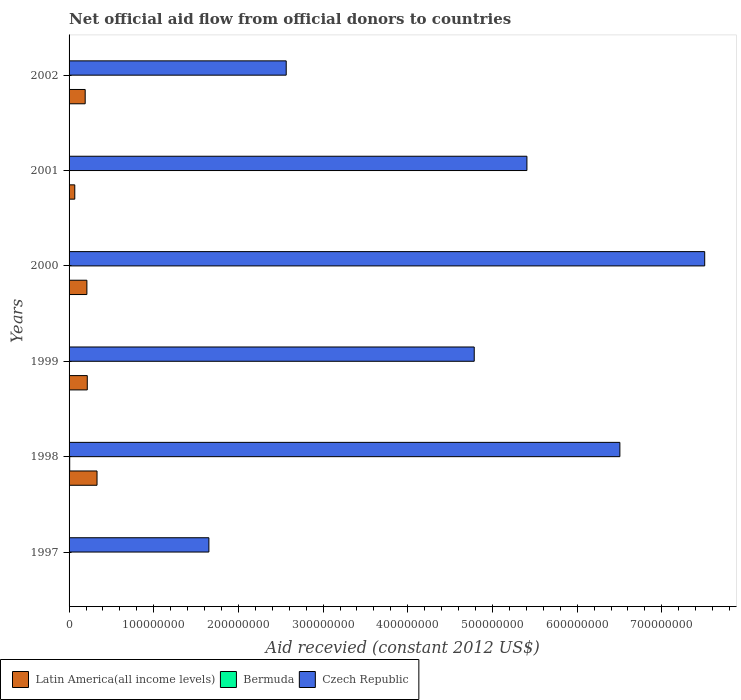What is the label of the 3rd group of bars from the top?
Provide a short and direct response. 2000. What is the total aid received in Bermuda in 1997?
Offer a terse response. 0. Across all years, what is the maximum total aid received in Latin America(all income levels)?
Provide a succinct answer. 3.30e+07. What is the total total aid received in Czech Republic in the graph?
Ensure brevity in your answer.  2.84e+09. What is the difference between the total aid received in Bermuda in 2001 and that in 2002?
Provide a succinct answer. 10000. What is the difference between the total aid received in Czech Republic in 1997 and the total aid received in Latin America(all income levels) in 2002?
Offer a terse response. 1.46e+08. What is the average total aid received in Czech Republic per year?
Offer a terse response. 4.74e+08. In the year 2001, what is the difference between the total aid received in Czech Republic and total aid received in Latin America(all income levels)?
Offer a terse response. 5.34e+08. What is the ratio of the total aid received in Czech Republic in 1997 to that in 1999?
Offer a terse response. 0.35. Is the difference between the total aid received in Czech Republic in 1998 and 2001 greater than the difference between the total aid received in Latin America(all income levels) in 1998 and 2001?
Your answer should be very brief. Yes. What is the difference between the highest and the second highest total aid received in Czech Republic?
Offer a terse response. 1.00e+08. What is the difference between the highest and the lowest total aid received in Bermuda?
Your response must be concise. 7.40e+05. Is it the case that in every year, the sum of the total aid received in Bermuda and total aid received in Czech Republic is greater than the total aid received in Latin America(all income levels)?
Ensure brevity in your answer.  Yes. How many bars are there?
Your answer should be compact. 16. Are all the bars in the graph horizontal?
Make the answer very short. Yes. How many years are there in the graph?
Provide a short and direct response. 6. Are the values on the major ticks of X-axis written in scientific E-notation?
Offer a terse response. No. Does the graph contain any zero values?
Ensure brevity in your answer.  Yes. Where does the legend appear in the graph?
Provide a short and direct response. Bottom left. What is the title of the graph?
Offer a terse response. Net official aid flow from official donors to countries. Does "Namibia" appear as one of the legend labels in the graph?
Provide a short and direct response. No. What is the label or title of the X-axis?
Provide a succinct answer. Aid recevied (constant 2012 US$). What is the Aid recevied (constant 2012 US$) of Czech Republic in 1997?
Give a very brief answer. 1.65e+08. What is the Aid recevied (constant 2012 US$) of Latin America(all income levels) in 1998?
Give a very brief answer. 3.30e+07. What is the Aid recevied (constant 2012 US$) in Bermuda in 1998?
Ensure brevity in your answer.  7.40e+05. What is the Aid recevied (constant 2012 US$) in Czech Republic in 1998?
Provide a short and direct response. 6.50e+08. What is the Aid recevied (constant 2012 US$) in Latin America(all income levels) in 1999?
Ensure brevity in your answer.  2.15e+07. What is the Aid recevied (constant 2012 US$) of Czech Republic in 1999?
Your response must be concise. 4.78e+08. What is the Aid recevied (constant 2012 US$) of Latin America(all income levels) in 2000?
Your response must be concise. 2.10e+07. What is the Aid recevied (constant 2012 US$) in Bermuda in 2000?
Provide a succinct answer. 1.10e+05. What is the Aid recevied (constant 2012 US$) of Czech Republic in 2000?
Offer a very short reply. 7.51e+08. What is the Aid recevied (constant 2012 US$) of Latin America(all income levels) in 2001?
Keep it short and to the point. 6.75e+06. What is the Aid recevied (constant 2012 US$) of Bermuda in 2001?
Your response must be concise. 4.00e+04. What is the Aid recevied (constant 2012 US$) in Czech Republic in 2001?
Provide a short and direct response. 5.41e+08. What is the Aid recevied (constant 2012 US$) of Latin America(all income levels) in 2002?
Your answer should be very brief. 1.90e+07. What is the Aid recevied (constant 2012 US$) in Bermuda in 2002?
Offer a very short reply. 3.00e+04. What is the Aid recevied (constant 2012 US$) of Czech Republic in 2002?
Keep it short and to the point. 2.56e+08. Across all years, what is the maximum Aid recevied (constant 2012 US$) of Latin America(all income levels)?
Offer a very short reply. 3.30e+07. Across all years, what is the maximum Aid recevied (constant 2012 US$) in Bermuda?
Your answer should be very brief. 7.40e+05. Across all years, what is the maximum Aid recevied (constant 2012 US$) in Czech Republic?
Your response must be concise. 7.51e+08. Across all years, what is the minimum Aid recevied (constant 2012 US$) in Latin America(all income levels)?
Offer a very short reply. 0. Across all years, what is the minimum Aid recevied (constant 2012 US$) in Bermuda?
Ensure brevity in your answer.  0. Across all years, what is the minimum Aid recevied (constant 2012 US$) of Czech Republic?
Give a very brief answer. 1.65e+08. What is the total Aid recevied (constant 2012 US$) of Latin America(all income levels) in the graph?
Your answer should be very brief. 1.01e+08. What is the total Aid recevied (constant 2012 US$) of Bermuda in the graph?
Make the answer very short. 1.05e+06. What is the total Aid recevied (constant 2012 US$) of Czech Republic in the graph?
Your answer should be compact. 2.84e+09. What is the difference between the Aid recevied (constant 2012 US$) of Czech Republic in 1997 and that in 1998?
Offer a very short reply. -4.85e+08. What is the difference between the Aid recevied (constant 2012 US$) of Czech Republic in 1997 and that in 1999?
Provide a short and direct response. -3.13e+08. What is the difference between the Aid recevied (constant 2012 US$) of Czech Republic in 1997 and that in 2000?
Offer a very short reply. -5.86e+08. What is the difference between the Aid recevied (constant 2012 US$) in Czech Republic in 1997 and that in 2001?
Your answer should be very brief. -3.76e+08. What is the difference between the Aid recevied (constant 2012 US$) in Czech Republic in 1997 and that in 2002?
Your response must be concise. -9.13e+07. What is the difference between the Aid recevied (constant 2012 US$) of Latin America(all income levels) in 1998 and that in 1999?
Offer a very short reply. 1.15e+07. What is the difference between the Aid recevied (constant 2012 US$) of Bermuda in 1998 and that in 1999?
Provide a succinct answer. 6.10e+05. What is the difference between the Aid recevied (constant 2012 US$) in Czech Republic in 1998 and that in 1999?
Offer a terse response. 1.72e+08. What is the difference between the Aid recevied (constant 2012 US$) of Latin America(all income levels) in 1998 and that in 2000?
Keep it short and to the point. 1.20e+07. What is the difference between the Aid recevied (constant 2012 US$) in Bermuda in 1998 and that in 2000?
Ensure brevity in your answer.  6.30e+05. What is the difference between the Aid recevied (constant 2012 US$) of Czech Republic in 1998 and that in 2000?
Ensure brevity in your answer.  -1.00e+08. What is the difference between the Aid recevied (constant 2012 US$) of Latin America(all income levels) in 1998 and that in 2001?
Offer a terse response. 2.63e+07. What is the difference between the Aid recevied (constant 2012 US$) in Czech Republic in 1998 and that in 2001?
Provide a succinct answer. 1.10e+08. What is the difference between the Aid recevied (constant 2012 US$) in Latin America(all income levels) in 1998 and that in 2002?
Offer a terse response. 1.40e+07. What is the difference between the Aid recevied (constant 2012 US$) in Bermuda in 1998 and that in 2002?
Offer a very short reply. 7.10e+05. What is the difference between the Aid recevied (constant 2012 US$) of Czech Republic in 1998 and that in 2002?
Ensure brevity in your answer.  3.94e+08. What is the difference between the Aid recevied (constant 2012 US$) of Latin America(all income levels) in 1999 and that in 2000?
Ensure brevity in your answer.  4.50e+05. What is the difference between the Aid recevied (constant 2012 US$) of Czech Republic in 1999 and that in 2000?
Offer a terse response. -2.72e+08. What is the difference between the Aid recevied (constant 2012 US$) in Latin America(all income levels) in 1999 and that in 2001?
Your answer should be compact. 1.48e+07. What is the difference between the Aid recevied (constant 2012 US$) in Czech Republic in 1999 and that in 2001?
Make the answer very short. -6.22e+07. What is the difference between the Aid recevied (constant 2012 US$) of Latin America(all income levels) in 1999 and that in 2002?
Your answer should be compact. 2.47e+06. What is the difference between the Aid recevied (constant 2012 US$) of Bermuda in 1999 and that in 2002?
Your response must be concise. 1.00e+05. What is the difference between the Aid recevied (constant 2012 US$) of Czech Republic in 1999 and that in 2002?
Make the answer very short. 2.22e+08. What is the difference between the Aid recevied (constant 2012 US$) in Latin America(all income levels) in 2000 and that in 2001?
Ensure brevity in your answer.  1.43e+07. What is the difference between the Aid recevied (constant 2012 US$) of Bermuda in 2000 and that in 2001?
Your answer should be very brief. 7.00e+04. What is the difference between the Aid recevied (constant 2012 US$) of Czech Republic in 2000 and that in 2001?
Give a very brief answer. 2.10e+08. What is the difference between the Aid recevied (constant 2012 US$) in Latin America(all income levels) in 2000 and that in 2002?
Your answer should be very brief. 2.02e+06. What is the difference between the Aid recevied (constant 2012 US$) of Czech Republic in 2000 and that in 2002?
Offer a very short reply. 4.94e+08. What is the difference between the Aid recevied (constant 2012 US$) in Latin America(all income levels) in 2001 and that in 2002?
Your answer should be compact. -1.23e+07. What is the difference between the Aid recevied (constant 2012 US$) in Bermuda in 2001 and that in 2002?
Provide a succinct answer. 10000. What is the difference between the Aid recevied (constant 2012 US$) of Czech Republic in 2001 and that in 2002?
Give a very brief answer. 2.84e+08. What is the difference between the Aid recevied (constant 2012 US$) in Latin America(all income levels) in 1998 and the Aid recevied (constant 2012 US$) in Bermuda in 1999?
Make the answer very short. 3.29e+07. What is the difference between the Aid recevied (constant 2012 US$) in Latin America(all income levels) in 1998 and the Aid recevied (constant 2012 US$) in Czech Republic in 1999?
Offer a terse response. -4.45e+08. What is the difference between the Aid recevied (constant 2012 US$) in Bermuda in 1998 and the Aid recevied (constant 2012 US$) in Czech Republic in 1999?
Give a very brief answer. -4.78e+08. What is the difference between the Aid recevied (constant 2012 US$) in Latin America(all income levels) in 1998 and the Aid recevied (constant 2012 US$) in Bermuda in 2000?
Offer a very short reply. 3.29e+07. What is the difference between the Aid recevied (constant 2012 US$) of Latin America(all income levels) in 1998 and the Aid recevied (constant 2012 US$) of Czech Republic in 2000?
Your response must be concise. -7.18e+08. What is the difference between the Aid recevied (constant 2012 US$) in Bermuda in 1998 and the Aid recevied (constant 2012 US$) in Czech Republic in 2000?
Ensure brevity in your answer.  -7.50e+08. What is the difference between the Aid recevied (constant 2012 US$) of Latin America(all income levels) in 1998 and the Aid recevied (constant 2012 US$) of Bermuda in 2001?
Keep it short and to the point. 3.30e+07. What is the difference between the Aid recevied (constant 2012 US$) of Latin America(all income levels) in 1998 and the Aid recevied (constant 2012 US$) of Czech Republic in 2001?
Make the answer very short. -5.08e+08. What is the difference between the Aid recevied (constant 2012 US$) of Bermuda in 1998 and the Aid recevied (constant 2012 US$) of Czech Republic in 2001?
Provide a succinct answer. -5.40e+08. What is the difference between the Aid recevied (constant 2012 US$) in Latin America(all income levels) in 1998 and the Aid recevied (constant 2012 US$) in Bermuda in 2002?
Offer a terse response. 3.30e+07. What is the difference between the Aid recevied (constant 2012 US$) in Latin America(all income levels) in 1998 and the Aid recevied (constant 2012 US$) in Czech Republic in 2002?
Your response must be concise. -2.23e+08. What is the difference between the Aid recevied (constant 2012 US$) of Bermuda in 1998 and the Aid recevied (constant 2012 US$) of Czech Republic in 2002?
Your answer should be very brief. -2.56e+08. What is the difference between the Aid recevied (constant 2012 US$) of Latin America(all income levels) in 1999 and the Aid recevied (constant 2012 US$) of Bermuda in 2000?
Make the answer very short. 2.14e+07. What is the difference between the Aid recevied (constant 2012 US$) of Latin America(all income levels) in 1999 and the Aid recevied (constant 2012 US$) of Czech Republic in 2000?
Provide a succinct answer. -7.29e+08. What is the difference between the Aid recevied (constant 2012 US$) of Bermuda in 1999 and the Aid recevied (constant 2012 US$) of Czech Republic in 2000?
Keep it short and to the point. -7.50e+08. What is the difference between the Aid recevied (constant 2012 US$) of Latin America(all income levels) in 1999 and the Aid recevied (constant 2012 US$) of Bermuda in 2001?
Ensure brevity in your answer.  2.15e+07. What is the difference between the Aid recevied (constant 2012 US$) of Latin America(all income levels) in 1999 and the Aid recevied (constant 2012 US$) of Czech Republic in 2001?
Make the answer very short. -5.19e+08. What is the difference between the Aid recevied (constant 2012 US$) of Bermuda in 1999 and the Aid recevied (constant 2012 US$) of Czech Republic in 2001?
Your answer should be very brief. -5.41e+08. What is the difference between the Aid recevied (constant 2012 US$) of Latin America(all income levels) in 1999 and the Aid recevied (constant 2012 US$) of Bermuda in 2002?
Offer a terse response. 2.15e+07. What is the difference between the Aid recevied (constant 2012 US$) in Latin America(all income levels) in 1999 and the Aid recevied (constant 2012 US$) in Czech Republic in 2002?
Give a very brief answer. -2.35e+08. What is the difference between the Aid recevied (constant 2012 US$) of Bermuda in 1999 and the Aid recevied (constant 2012 US$) of Czech Republic in 2002?
Provide a short and direct response. -2.56e+08. What is the difference between the Aid recevied (constant 2012 US$) in Latin America(all income levels) in 2000 and the Aid recevied (constant 2012 US$) in Bermuda in 2001?
Your answer should be very brief. 2.10e+07. What is the difference between the Aid recevied (constant 2012 US$) in Latin America(all income levels) in 2000 and the Aid recevied (constant 2012 US$) in Czech Republic in 2001?
Keep it short and to the point. -5.20e+08. What is the difference between the Aid recevied (constant 2012 US$) in Bermuda in 2000 and the Aid recevied (constant 2012 US$) in Czech Republic in 2001?
Offer a very short reply. -5.41e+08. What is the difference between the Aid recevied (constant 2012 US$) in Latin America(all income levels) in 2000 and the Aid recevied (constant 2012 US$) in Bermuda in 2002?
Your answer should be compact. 2.10e+07. What is the difference between the Aid recevied (constant 2012 US$) in Latin America(all income levels) in 2000 and the Aid recevied (constant 2012 US$) in Czech Republic in 2002?
Your answer should be very brief. -2.35e+08. What is the difference between the Aid recevied (constant 2012 US$) of Bermuda in 2000 and the Aid recevied (constant 2012 US$) of Czech Republic in 2002?
Your answer should be compact. -2.56e+08. What is the difference between the Aid recevied (constant 2012 US$) in Latin America(all income levels) in 2001 and the Aid recevied (constant 2012 US$) in Bermuda in 2002?
Offer a very short reply. 6.72e+06. What is the difference between the Aid recevied (constant 2012 US$) in Latin America(all income levels) in 2001 and the Aid recevied (constant 2012 US$) in Czech Republic in 2002?
Offer a terse response. -2.50e+08. What is the difference between the Aid recevied (constant 2012 US$) of Bermuda in 2001 and the Aid recevied (constant 2012 US$) of Czech Republic in 2002?
Offer a very short reply. -2.56e+08. What is the average Aid recevied (constant 2012 US$) of Latin America(all income levels) per year?
Provide a succinct answer. 1.69e+07. What is the average Aid recevied (constant 2012 US$) in Bermuda per year?
Keep it short and to the point. 1.75e+05. What is the average Aid recevied (constant 2012 US$) in Czech Republic per year?
Ensure brevity in your answer.  4.74e+08. In the year 1998, what is the difference between the Aid recevied (constant 2012 US$) in Latin America(all income levels) and Aid recevied (constant 2012 US$) in Bermuda?
Give a very brief answer. 3.23e+07. In the year 1998, what is the difference between the Aid recevied (constant 2012 US$) of Latin America(all income levels) and Aid recevied (constant 2012 US$) of Czech Republic?
Make the answer very short. -6.17e+08. In the year 1998, what is the difference between the Aid recevied (constant 2012 US$) of Bermuda and Aid recevied (constant 2012 US$) of Czech Republic?
Your response must be concise. -6.50e+08. In the year 1999, what is the difference between the Aid recevied (constant 2012 US$) in Latin America(all income levels) and Aid recevied (constant 2012 US$) in Bermuda?
Offer a terse response. 2.14e+07. In the year 1999, what is the difference between the Aid recevied (constant 2012 US$) of Latin America(all income levels) and Aid recevied (constant 2012 US$) of Czech Republic?
Offer a very short reply. -4.57e+08. In the year 1999, what is the difference between the Aid recevied (constant 2012 US$) of Bermuda and Aid recevied (constant 2012 US$) of Czech Republic?
Offer a terse response. -4.78e+08. In the year 2000, what is the difference between the Aid recevied (constant 2012 US$) in Latin America(all income levels) and Aid recevied (constant 2012 US$) in Bermuda?
Ensure brevity in your answer.  2.09e+07. In the year 2000, what is the difference between the Aid recevied (constant 2012 US$) in Latin America(all income levels) and Aid recevied (constant 2012 US$) in Czech Republic?
Provide a succinct answer. -7.30e+08. In the year 2000, what is the difference between the Aid recevied (constant 2012 US$) of Bermuda and Aid recevied (constant 2012 US$) of Czech Republic?
Ensure brevity in your answer.  -7.51e+08. In the year 2001, what is the difference between the Aid recevied (constant 2012 US$) of Latin America(all income levels) and Aid recevied (constant 2012 US$) of Bermuda?
Your answer should be compact. 6.71e+06. In the year 2001, what is the difference between the Aid recevied (constant 2012 US$) in Latin America(all income levels) and Aid recevied (constant 2012 US$) in Czech Republic?
Your response must be concise. -5.34e+08. In the year 2001, what is the difference between the Aid recevied (constant 2012 US$) of Bermuda and Aid recevied (constant 2012 US$) of Czech Republic?
Make the answer very short. -5.41e+08. In the year 2002, what is the difference between the Aid recevied (constant 2012 US$) of Latin America(all income levels) and Aid recevied (constant 2012 US$) of Bermuda?
Your answer should be compact. 1.90e+07. In the year 2002, what is the difference between the Aid recevied (constant 2012 US$) in Latin America(all income levels) and Aid recevied (constant 2012 US$) in Czech Republic?
Offer a terse response. -2.37e+08. In the year 2002, what is the difference between the Aid recevied (constant 2012 US$) in Bermuda and Aid recevied (constant 2012 US$) in Czech Republic?
Provide a succinct answer. -2.56e+08. What is the ratio of the Aid recevied (constant 2012 US$) of Czech Republic in 1997 to that in 1998?
Give a very brief answer. 0.25. What is the ratio of the Aid recevied (constant 2012 US$) in Czech Republic in 1997 to that in 1999?
Provide a short and direct response. 0.35. What is the ratio of the Aid recevied (constant 2012 US$) of Czech Republic in 1997 to that in 2000?
Your answer should be compact. 0.22. What is the ratio of the Aid recevied (constant 2012 US$) in Czech Republic in 1997 to that in 2001?
Offer a very short reply. 0.31. What is the ratio of the Aid recevied (constant 2012 US$) of Czech Republic in 1997 to that in 2002?
Provide a succinct answer. 0.64. What is the ratio of the Aid recevied (constant 2012 US$) of Latin America(all income levels) in 1998 to that in 1999?
Give a very brief answer. 1.54. What is the ratio of the Aid recevied (constant 2012 US$) in Bermuda in 1998 to that in 1999?
Your answer should be compact. 5.69. What is the ratio of the Aid recevied (constant 2012 US$) in Czech Republic in 1998 to that in 1999?
Provide a succinct answer. 1.36. What is the ratio of the Aid recevied (constant 2012 US$) of Latin America(all income levels) in 1998 to that in 2000?
Provide a short and direct response. 1.57. What is the ratio of the Aid recevied (constant 2012 US$) of Bermuda in 1998 to that in 2000?
Your response must be concise. 6.73. What is the ratio of the Aid recevied (constant 2012 US$) of Czech Republic in 1998 to that in 2000?
Provide a succinct answer. 0.87. What is the ratio of the Aid recevied (constant 2012 US$) in Latin America(all income levels) in 1998 to that in 2001?
Make the answer very short. 4.89. What is the ratio of the Aid recevied (constant 2012 US$) of Czech Republic in 1998 to that in 2001?
Your answer should be compact. 1.2. What is the ratio of the Aid recevied (constant 2012 US$) in Latin America(all income levels) in 1998 to that in 2002?
Offer a terse response. 1.73. What is the ratio of the Aid recevied (constant 2012 US$) of Bermuda in 1998 to that in 2002?
Make the answer very short. 24.67. What is the ratio of the Aid recevied (constant 2012 US$) in Czech Republic in 1998 to that in 2002?
Make the answer very short. 2.54. What is the ratio of the Aid recevied (constant 2012 US$) in Latin America(all income levels) in 1999 to that in 2000?
Offer a terse response. 1.02. What is the ratio of the Aid recevied (constant 2012 US$) of Bermuda in 1999 to that in 2000?
Keep it short and to the point. 1.18. What is the ratio of the Aid recevied (constant 2012 US$) in Czech Republic in 1999 to that in 2000?
Provide a succinct answer. 0.64. What is the ratio of the Aid recevied (constant 2012 US$) of Latin America(all income levels) in 1999 to that in 2001?
Your answer should be compact. 3.19. What is the ratio of the Aid recevied (constant 2012 US$) in Czech Republic in 1999 to that in 2001?
Make the answer very short. 0.88. What is the ratio of the Aid recevied (constant 2012 US$) in Latin America(all income levels) in 1999 to that in 2002?
Give a very brief answer. 1.13. What is the ratio of the Aid recevied (constant 2012 US$) of Bermuda in 1999 to that in 2002?
Your answer should be very brief. 4.33. What is the ratio of the Aid recevied (constant 2012 US$) of Czech Republic in 1999 to that in 2002?
Provide a succinct answer. 1.87. What is the ratio of the Aid recevied (constant 2012 US$) in Latin America(all income levels) in 2000 to that in 2001?
Your answer should be compact. 3.12. What is the ratio of the Aid recevied (constant 2012 US$) of Bermuda in 2000 to that in 2001?
Provide a short and direct response. 2.75. What is the ratio of the Aid recevied (constant 2012 US$) of Czech Republic in 2000 to that in 2001?
Provide a short and direct response. 1.39. What is the ratio of the Aid recevied (constant 2012 US$) of Latin America(all income levels) in 2000 to that in 2002?
Your answer should be very brief. 1.11. What is the ratio of the Aid recevied (constant 2012 US$) in Bermuda in 2000 to that in 2002?
Keep it short and to the point. 3.67. What is the ratio of the Aid recevied (constant 2012 US$) in Czech Republic in 2000 to that in 2002?
Provide a short and direct response. 2.93. What is the ratio of the Aid recevied (constant 2012 US$) in Latin America(all income levels) in 2001 to that in 2002?
Provide a succinct answer. 0.35. What is the ratio of the Aid recevied (constant 2012 US$) in Czech Republic in 2001 to that in 2002?
Make the answer very short. 2.11. What is the difference between the highest and the second highest Aid recevied (constant 2012 US$) of Latin America(all income levels)?
Your answer should be compact. 1.15e+07. What is the difference between the highest and the second highest Aid recevied (constant 2012 US$) in Czech Republic?
Give a very brief answer. 1.00e+08. What is the difference between the highest and the lowest Aid recevied (constant 2012 US$) in Latin America(all income levels)?
Give a very brief answer. 3.30e+07. What is the difference between the highest and the lowest Aid recevied (constant 2012 US$) in Bermuda?
Offer a terse response. 7.40e+05. What is the difference between the highest and the lowest Aid recevied (constant 2012 US$) in Czech Republic?
Make the answer very short. 5.86e+08. 